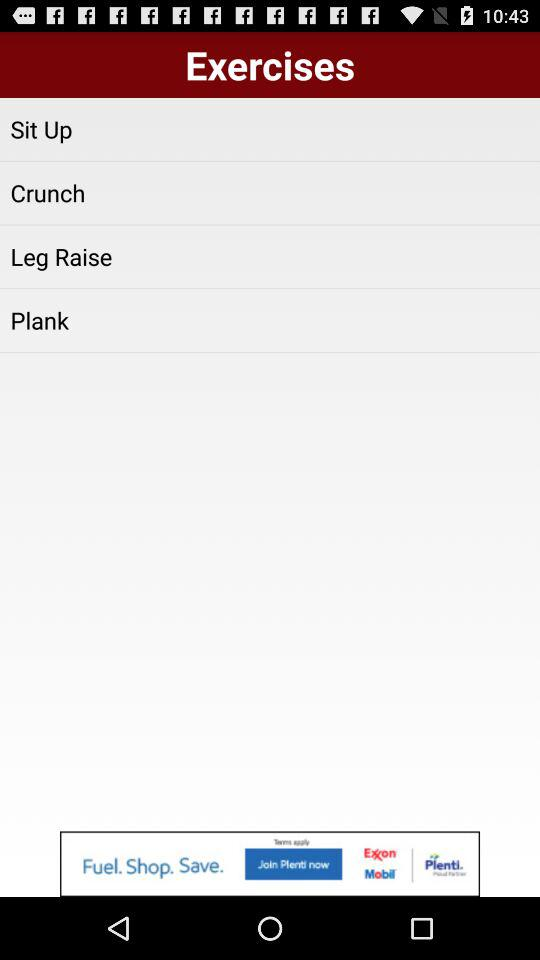How many crunches have been completed?
When the provided information is insufficient, respond with <no answer>. <no answer> 